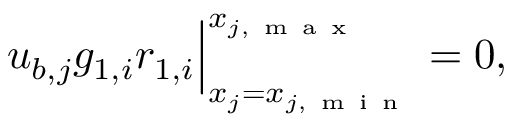<formula> <loc_0><loc_0><loc_500><loc_500>\begin{array} { r } { u _ { b , j } g _ { 1 , i } r _ { 1 , i } \Big | _ { x _ { j } = x _ { j , m i n } } ^ { x _ { j , m a x } } = 0 , } \end{array}</formula> 